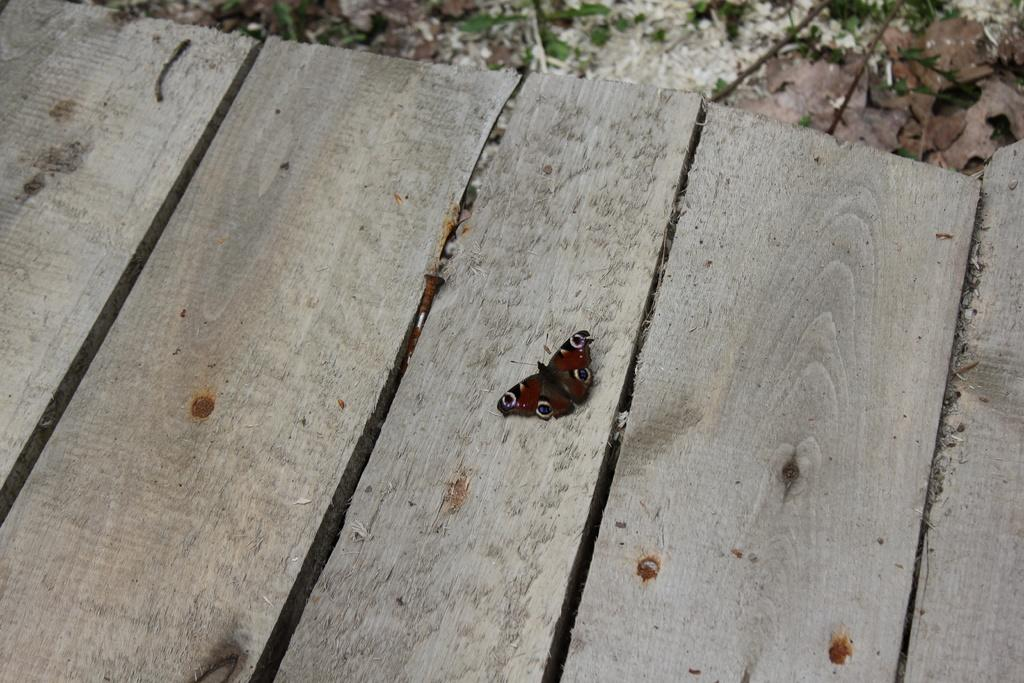What is on the wooden railing in the image? There is a butterfly on the wooden railing. What else can be seen on the railing? There are nails on the railing. What can be seen in the background of the image? There is a plant visible in the background. What type of cord is being used to hang the holiday decorations in the image? There are no holiday decorations or cords present in the image; it features a butterfly on a wooden railing with nails and a plant in the background. 